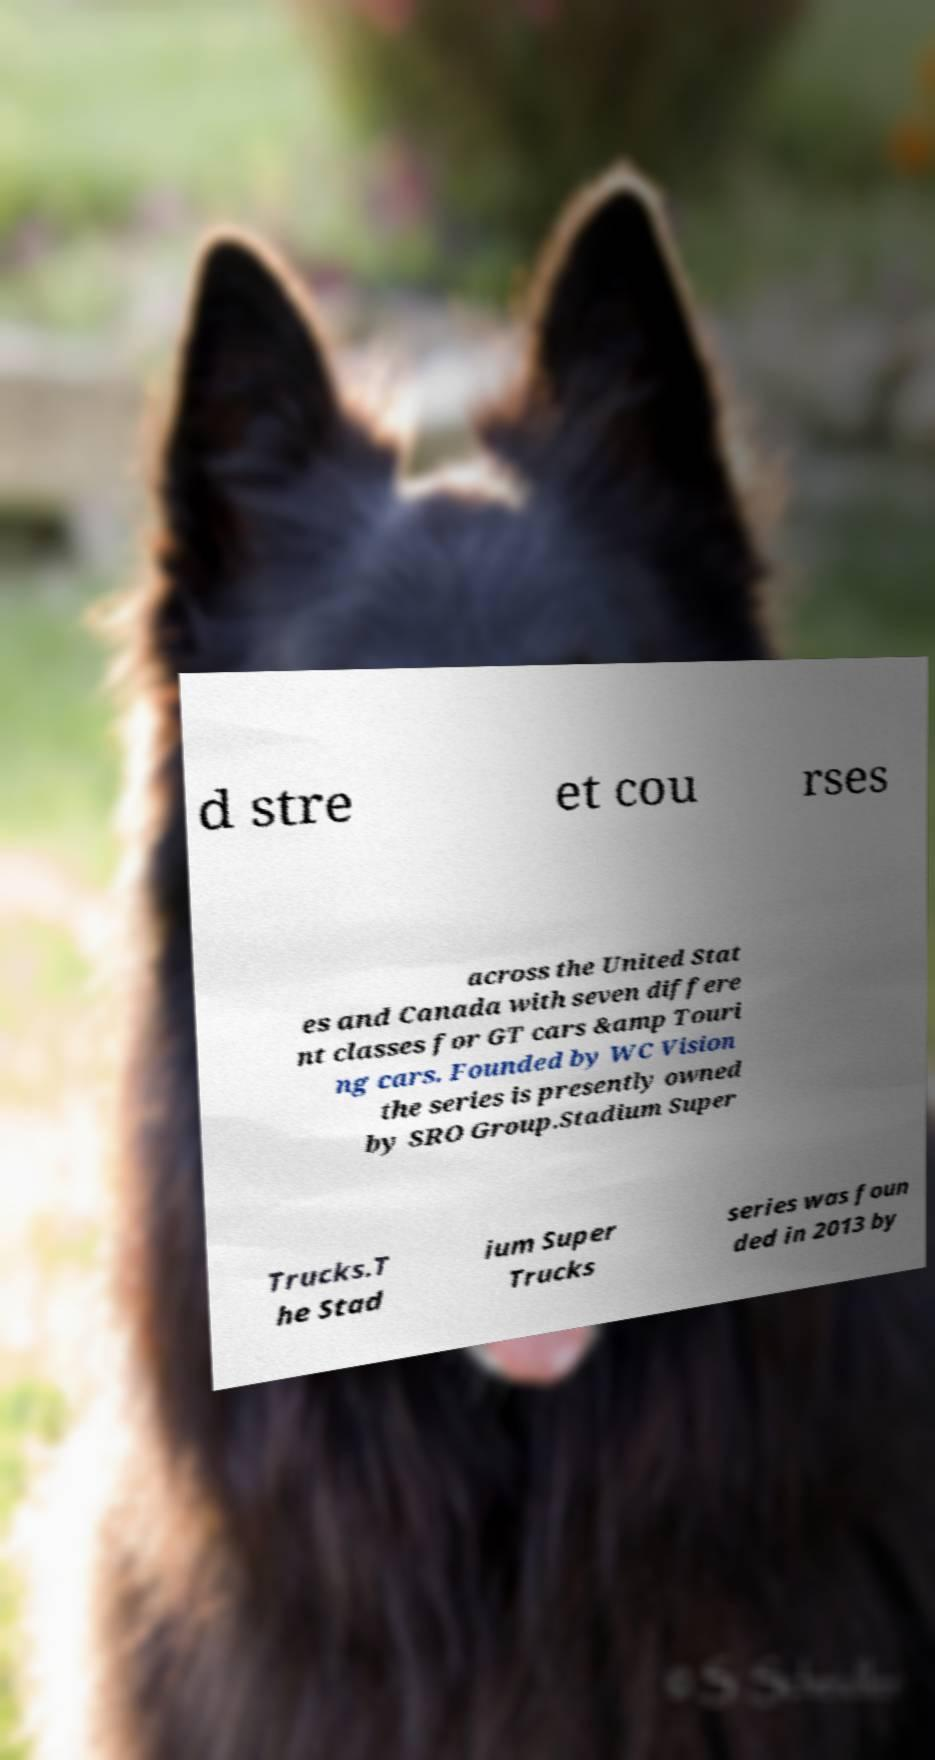For documentation purposes, I need the text within this image transcribed. Could you provide that? d stre et cou rses across the United Stat es and Canada with seven differe nt classes for GT cars &amp Touri ng cars. Founded by WC Vision the series is presently owned by SRO Group.Stadium Super Trucks.T he Stad ium Super Trucks series was foun ded in 2013 by 